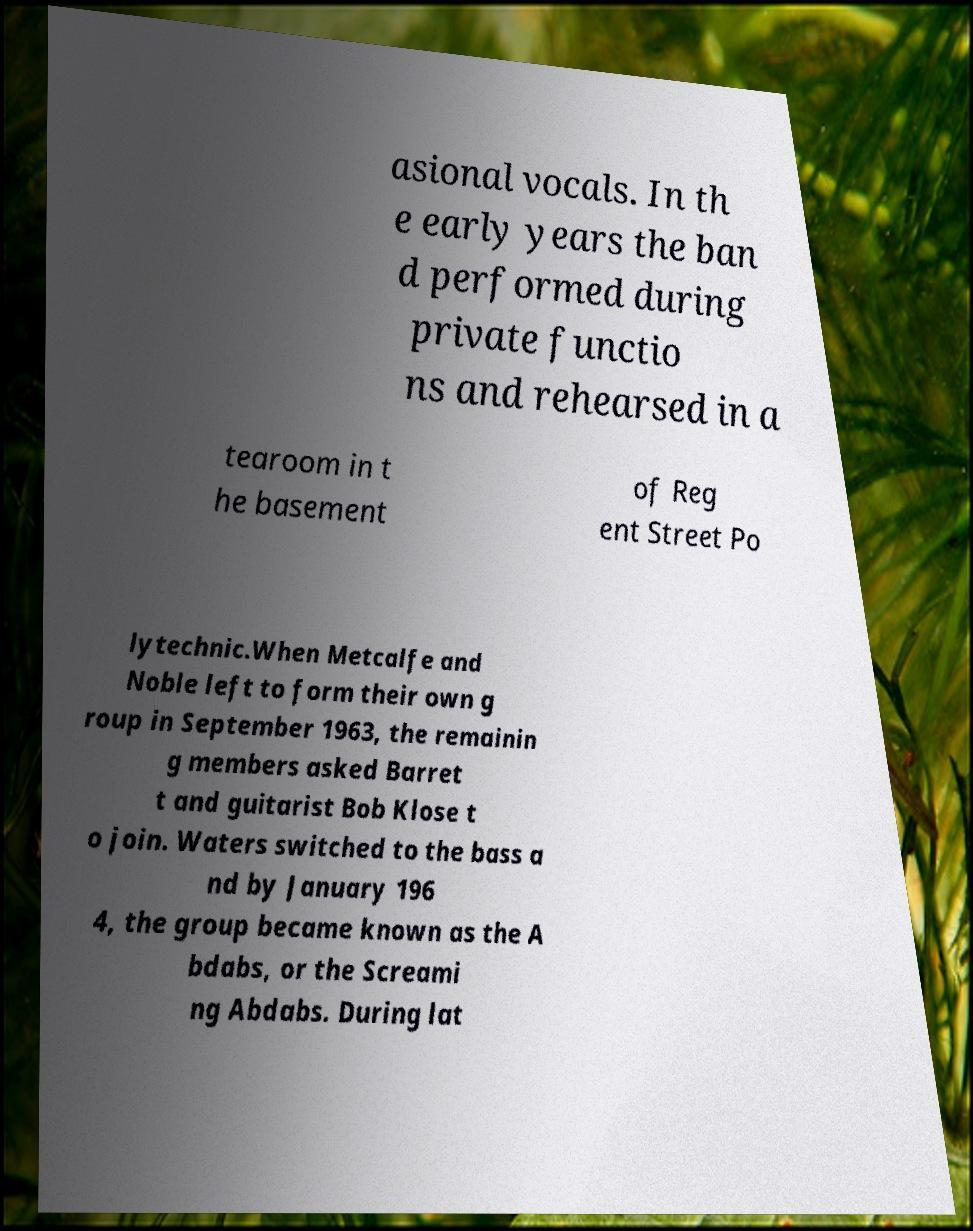Please read and relay the text visible in this image. What does it say? asional vocals. In th e early years the ban d performed during private functio ns and rehearsed in a tearoom in t he basement of Reg ent Street Po lytechnic.When Metcalfe and Noble left to form their own g roup in September 1963, the remainin g members asked Barret t and guitarist Bob Klose t o join. Waters switched to the bass a nd by January 196 4, the group became known as the A bdabs, or the Screami ng Abdabs. During lat 